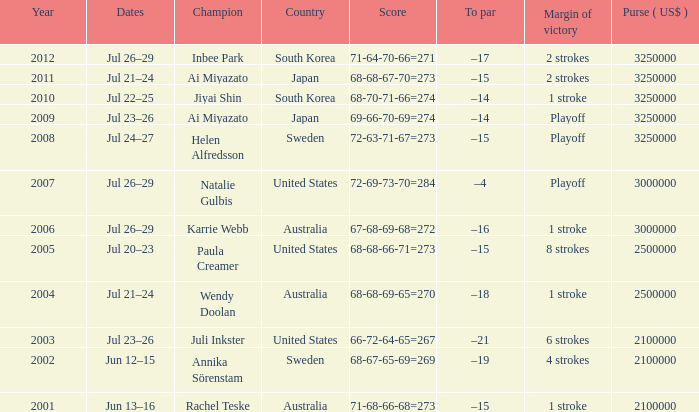Could you parse the entire table as a dict? {'header': ['Year', 'Dates', 'Champion', 'Country', 'Score', 'To par', 'Margin of victory', 'Purse ( US$ )'], 'rows': [['2012', 'Jul 26–29', 'Inbee Park', 'South Korea', '71-64-70-66=271', '–17', '2 strokes', '3250000'], ['2011', 'Jul 21–24', 'Ai Miyazato', 'Japan', '68-68-67-70=273', '–15', '2 strokes', '3250000'], ['2010', 'Jul 22–25', 'Jiyai Shin', 'South Korea', '68-70-71-66=274', '–14', '1 stroke', '3250000'], ['2009', 'Jul 23–26', 'Ai Miyazato', 'Japan', '69-66-70-69=274', '–14', 'Playoff', '3250000'], ['2008', 'Jul 24–27', 'Helen Alfredsson', 'Sweden', '72-63-71-67=273', '–15', 'Playoff', '3250000'], ['2007', 'Jul 26–29', 'Natalie Gulbis', 'United States', '72-69-73-70=284', '–4', 'Playoff', '3000000'], ['2006', 'Jul 26–29', 'Karrie Webb', 'Australia', '67-68-69-68=272', '–16', '1 stroke', '3000000'], ['2005', 'Jul 20–23', 'Paula Creamer', 'United States', '68-68-66-71=273', '–15', '8 strokes', '2500000'], ['2004', 'Jul 21–24', 'Wendy Doolan', 'Australia', '68-68-69-65=270', '–18', '1 stroke', '2500000'], ['2003', 'Jul 23–26', 'Juli Inkster', 'United States', '66-72-64-65=267', '–21', '6 strokes', '2100000'], ['2002', 'Jun 12–15', 'Annika Sörenstam', 'Sweden', '68-67-65-69=269', '–19', '4 strokes', '2100000'], ['2001', 'Jun 13–16', 'Rachel Teske', 'Australia', '71-68-66-68=273', '–15', '1 stroke', '2100000']]} At what date is the score 66-72-64-65=267? Jul 23–26. 